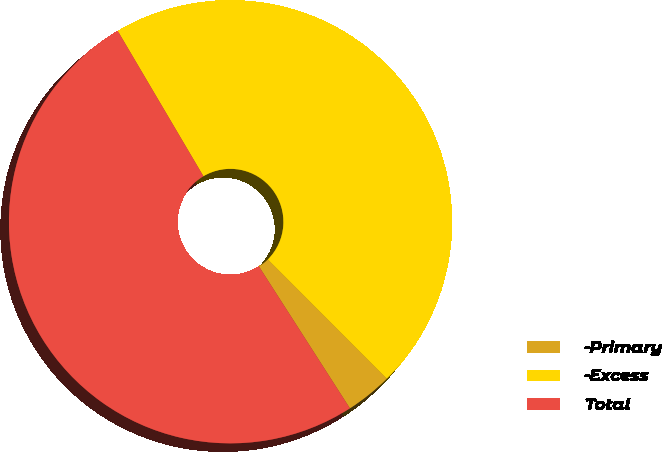Convert chart to OTSL. <chart><loc_0><loc_0><loc_500><loc_500><pie_chart><fcel>-Primary<fcel>-Excess<fcel>Total<nl><fcel>3.41%<fcel>45.99%<fcel>50.59%<nl></chart> 